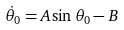Convert formula to latex. <formula><loc_0><loc_0><loc_500><loc_500>\dot { \theta } _ { 0 } = A \sin \theta _ { 0 } - B</formula> 